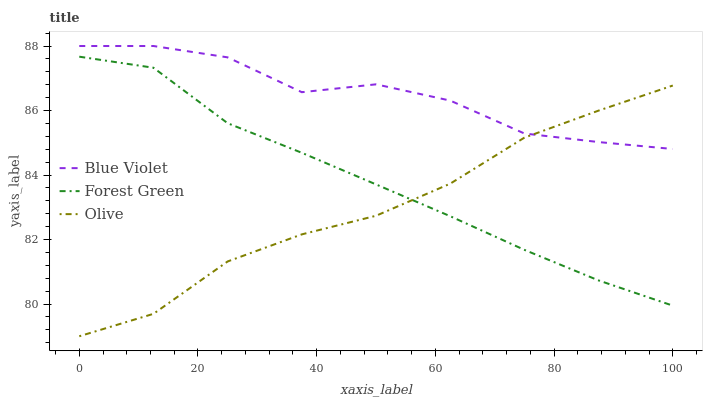Does Olive have the minimum area under the curve?
Answer yes or no. Yes. Does Blue Violet have the maximum area under the curve?
Answer yes or no. Yes. Does Forest Green have the minimum area under the curve?
Answer yes or no. No. Does Forest Green have the maximum area under the curve?
Answer yes or no. No. Is Forest Green the smoothest?
Answer yes or no. Yes. Is Blue Violet the roughest?
Answer yes or no. Yes. Is Blue Violet the smoothest?
Answer yes or no. No. Is Forest Green the roughest?
Answer yes or no. No. Does Olive have the lowest value?
Answer yes or no. Yes. Does Forest Green have the lowest value?
Answer yes or no. No. Does Blue Violet have the highest value?
Answer yes or no. Yes. Does Forest Green have the highest value?
Answer yes or no. No. Is Forest Green less than Blue Violet?
Answer yes or no. Yes. Is Blue Violet greater than Forest Green?
Answer yes or no. Yes. Does Blue Violet intersect Olive?
Answer yes or no. Yes. Is Blue Violet less than Olive?
Answer yes or no. No. Is Blue Violet greater than Olive?
Answer yes or no. No. Does Forest Green intersect Blue Violet?
Answer yes or no. No. 